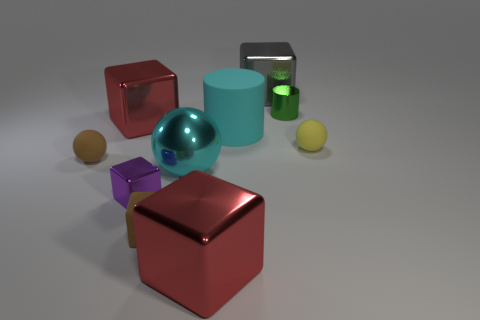Are there any red objects of the same size as the brown sphere?
Make the answer very short. No. There is a tiny sphere on the left side of the large gray object; what is its material?
Provide a short and direct response. Rubber. Do the cylinder to the right of the gray thing and the cyan cylinder have the same material?
Keep it short and to the point. No. The yellow object that is the same size as the purple thing is what shape?
Give a very brief answer. Sphere. What number of other balls have the same color as the metal ball?
Offer a terse response. 0. Are there fewer metal cubes that are on the right side of the matte block than cylinders that are in front of the purple thing?
Your answer should be compact. No. Are there any large cylinders in front of the cyan shiny object?
Give a very brief answer. No. Is there a cyan shiny sphere behind the matte object that is to the right of the tiny metal object that is to the right of the gray metal block?
Your answer should be very brief. No. There is a red metal object behind the small yellow sphere; is it the same shape as the cyan metal thing?
Ensure brevity in your answer.  No. What is the color of the ball that is made of the same material as the gray block?
Your response must be concise. Cyan. 